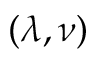<formula> <loc_0><loc_0><loc_500><loc_500>( \lambda , \nu )</formula> 